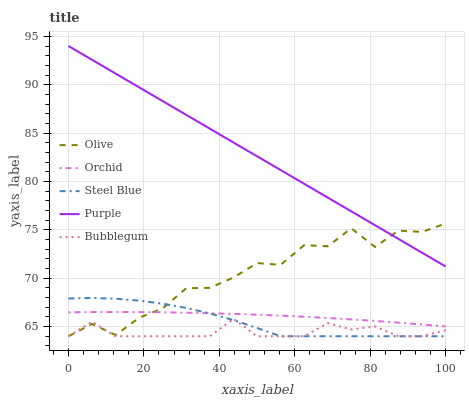Does Bubblegum have the minimum area under the curve?
Answer yes or no. Yes. Does Purple have the maximum area under the curve?
Answer yes or no. Yes. Does Steel Blue have the minimum area under the curve?
Answer yes or no. No. Does Steel Blue have the maximum area under the curve?
Answer yes or no. No. Is Purple the smoothest?
Answer yes or no. Yes. Is Olive the roughest?
Answer yes or no. Yes. Is Steel Blue the smoothest?
Answer yes or no. No. Is Steel Blue the roughest?
Answer yes or no. No. Does Olive have the lowest value?
Answer yes or no. Yes. Does Purple have the lowest value?
Answer yes or no. No. Does Purple have the highest value?
Answer yes or no. Yes. Does Steel Blue have the highest value?
Answer yes or no. No. Is Bubblegum less than Purple?
Answer yes or no. Yes. Is Purple greater than Orchid?
Answer yes or no. Yes. Does Orchid intersect Olive?
Answer yes or no. Yes. Is Orchid less than Olive?
Answer yes or no. No. Is Orchid greater than Olive?
Answer yes or no. No. Does Bubblegum intersect Purple?
Answer yes or no. No. 